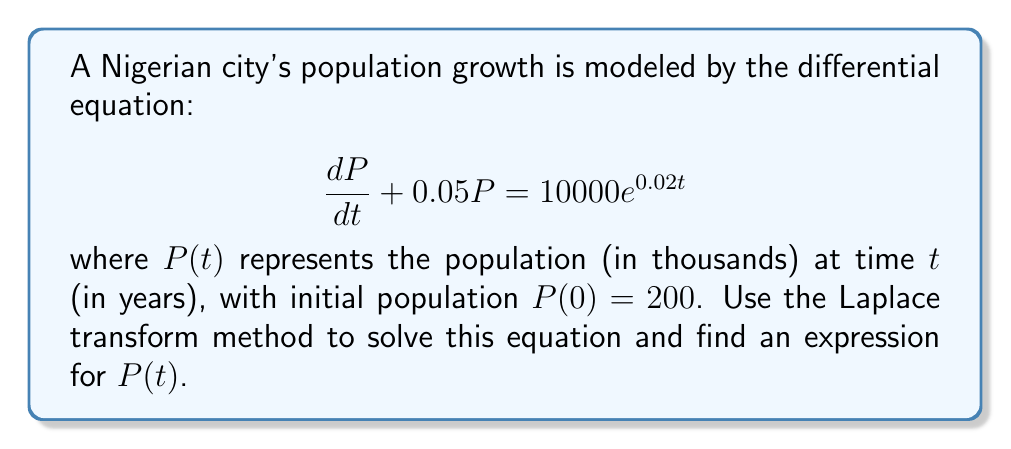Can you solve this math problem? Let's solve this step-by-step using Laplace transforms:

1) Take the Laplace transform of both sides of the equation:
   $$\mathcal{L}\left\{\frac{dP}{dt} + 0.05P\right\} = \mathcal{L}\{10000e^{0.02t}\}$$

2) Using Laplace transform properties:
   $$sP(s) - P(0) + 0.05P(s) = \frac{10000}{s-0.02}$$

3) Substitute $P(0) = 200$:
   $$sP(s) - 200 + 0.05P(s) = \frac{10000}{s-0.02}$$

4) Rearrange terms:
   $$(s + 0.05)P(s) = \frac{10000}{s-0.02} + 200$$

5) Solve for $P(s)$:
   $$P(s) = \frac{10000}{(s-0.02)(s+0.05)} + \frac{200}{s+0.05}$$

6) Perform partial fraction decomposition:
   $$P(s) = \frac{A}{s-0.02} + \frac{B}{s+0.05}$$
   where $A = \frac{10000}{0.07} \approx 142857.14$ and $B = 200 - A \approx -142657.14$

7) Take the inverse Laplace transform:
   $$P(t) = Ae^{0.02t} + Be^{-0.05t}$$

8) Substitute the values of $A$ and $B$:
   $$P(t) \approx 142857.14e^{0.02t} - 142657.14e^{-0.05t}$$

This expression represents the population of the Nigerian city in thousands at time $t$ in years.
Answer: $P(t) \approx 142857.14e^{0.02t} - 142657.14e^{-0.05t}$ 